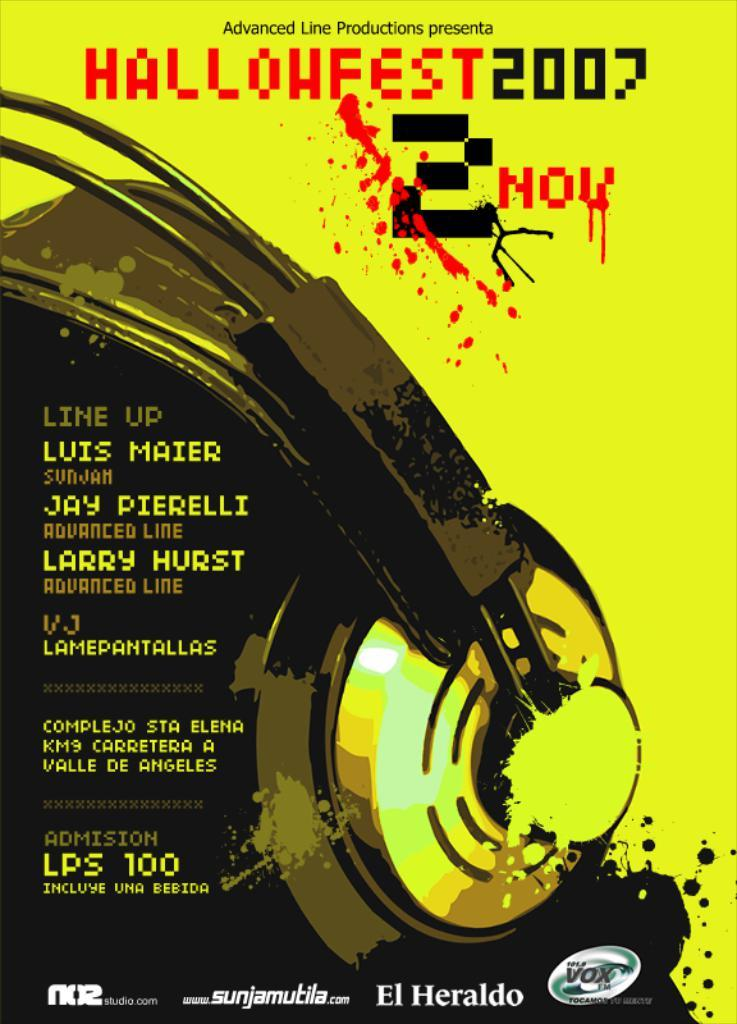<image>
Give a short and clear explanation of the subsequent image. A Hallowfest 2007 poster features a set of headphones. 